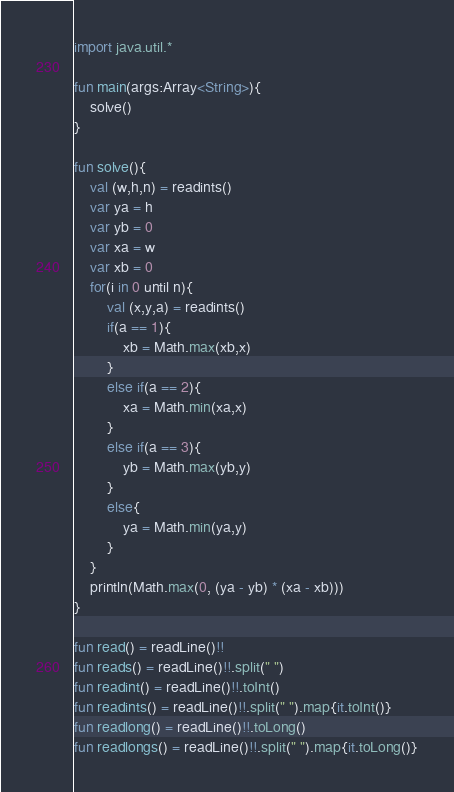Convert code to text. <code><loc_0><loc_0><loc_500><loc_500><_Kotlin_>import java.util.*

fun main(args:Array<String>){
    solve()
}

fun solve(){
    val (w,h,n) = readints()
    var ya = h
    var yb = 0
    var xa = w
    var xb = 0
    for(i in 0 until n){
        val (x,y,a) = readints()
        if(a == 1){
            xb = Math.max(xb,x)
        }
        else if(a == 2){
            xa = Math.min(xa,x)
        }
        else if(a == 3){
            yb = Math.max(yb,y)
        }
        else{
            ya = Math.min(ya,y)
        }
    }
    println(Math.max(0, (ya - yb) * (xa - xb)))
}

fun read() = readLine()!!
fun reads() = readLine()!!.split(" ")
fun readint() = readLine()!!.toInt()
fun readints() = readLine()!!.split(" ").map{it.toInt()}
fun readlong() = readLine()!!.toLong()
fun readlongs() = readLine()!!.split(" ").map{it.toLong()}</code> 